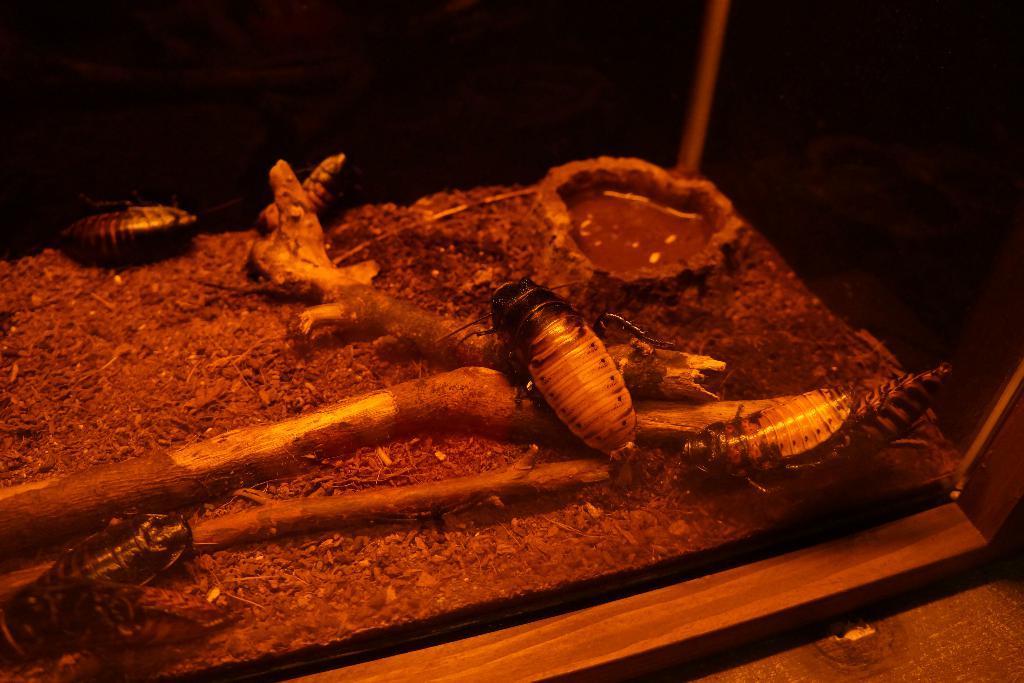Describe this image in one or two sentences. In the image we can see there are many insects, this is a wooden stick and a container. 